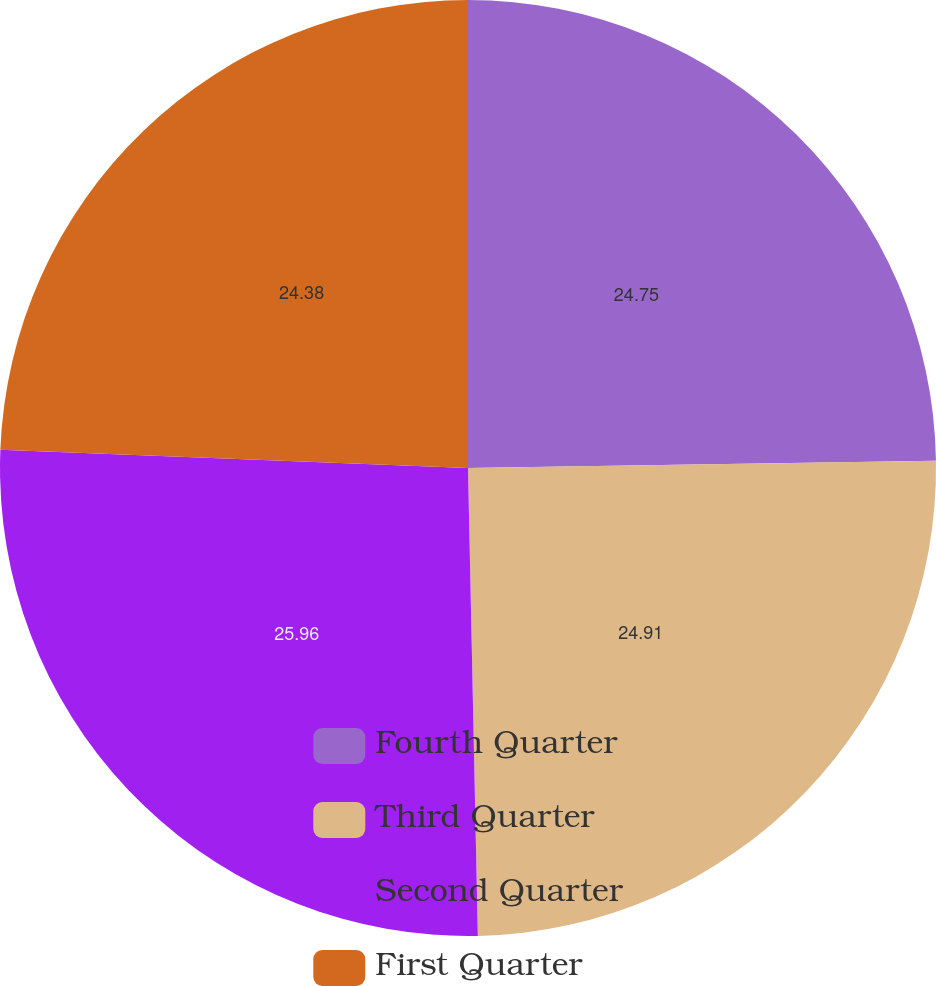Convert chart to OTSL. <chart><loc_0><loc_0><loc_500><loc_500><pie_chart><fcel>Fourth Quarter<fcel>Third Quarter<fcel>Second Quarter<fcel>First Quarter<nl><fcel>24.75%<fcel>24.91%<fcel>25.95%<fcel>24.38%<nl></chart> 